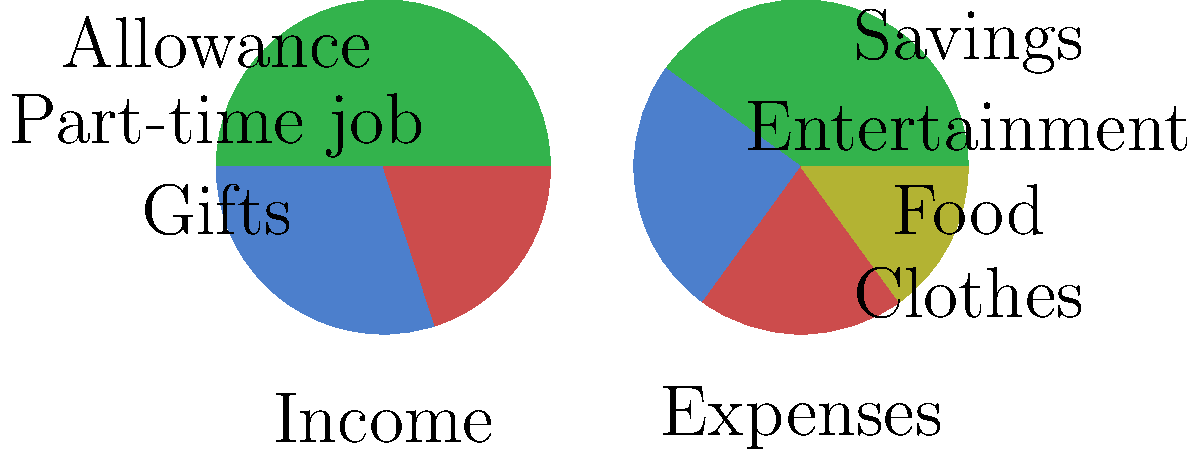Based on the pie charts showing a teenager's monthly income and expenses, what percentage of their income should they aim to save to develop good financial habits? To determine an appropriate savings percentage for the teenager, let's analyze the income and expense charts:

1. Income breakdown:
   - Allowance: 50%
   - Part-time job: 30%
   - Gifts: 20%

2. Expense breakdown:
   - Savings: 40%
   - Entertainment: 25%
   - Food: 20%
   - Clothes: 15%

3. Current savings rate:
   The teenager is already saving 40% of their income, which is an excellent habit.

4. Financial experts often recommend the 50/30/20 rule for budgeting:
   - 50% for needs
   - 30% for wants
   - 20% for savings and debt repayment

5. In this case, the teenager is exceeding the recommended savings rate, which is commendable for building financial literacy and future financial stability.

6. However, it's important to maintain a balance between saving and enjoying the present. The current 40% savings rate is appropriate for a teenager without significant financial responsibilities.

7. To develop good financial habits, the teenager should aim to save at least 20% of their income, which aligns with the 50/30/20 rule and allows for some flexibility in spending on wants and needs.
Answer: At least 20% 